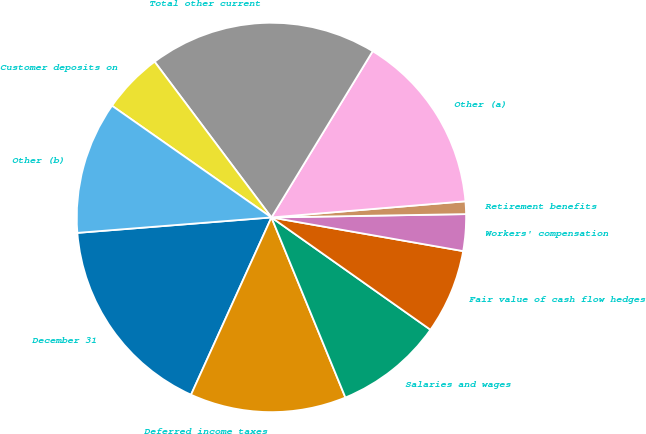Convert chart to OTSL. <chart><loc_0><loc_0><loc_500><loc_500><pie_chart><fcel>December 31<fcel>Deferred income taxes<fcel>Salaries and wages<fcel>Fair value of cash flow hedges<fcel>Workers' compensation<fcel>Retirement benefits<fcel>Other (a)<fcel>Total other current<fcel>Customer deposits on<fcel>Other (b)<nl><fcel>16.96%<fcel>12.98%<fcel>9.01%<fcel>7.02%<fcel>3.04%<fcel>1.05%<fcel>14.97%<fcel>18.95%<fcel>5.03%<fcel>10.99%<nl></chart> 